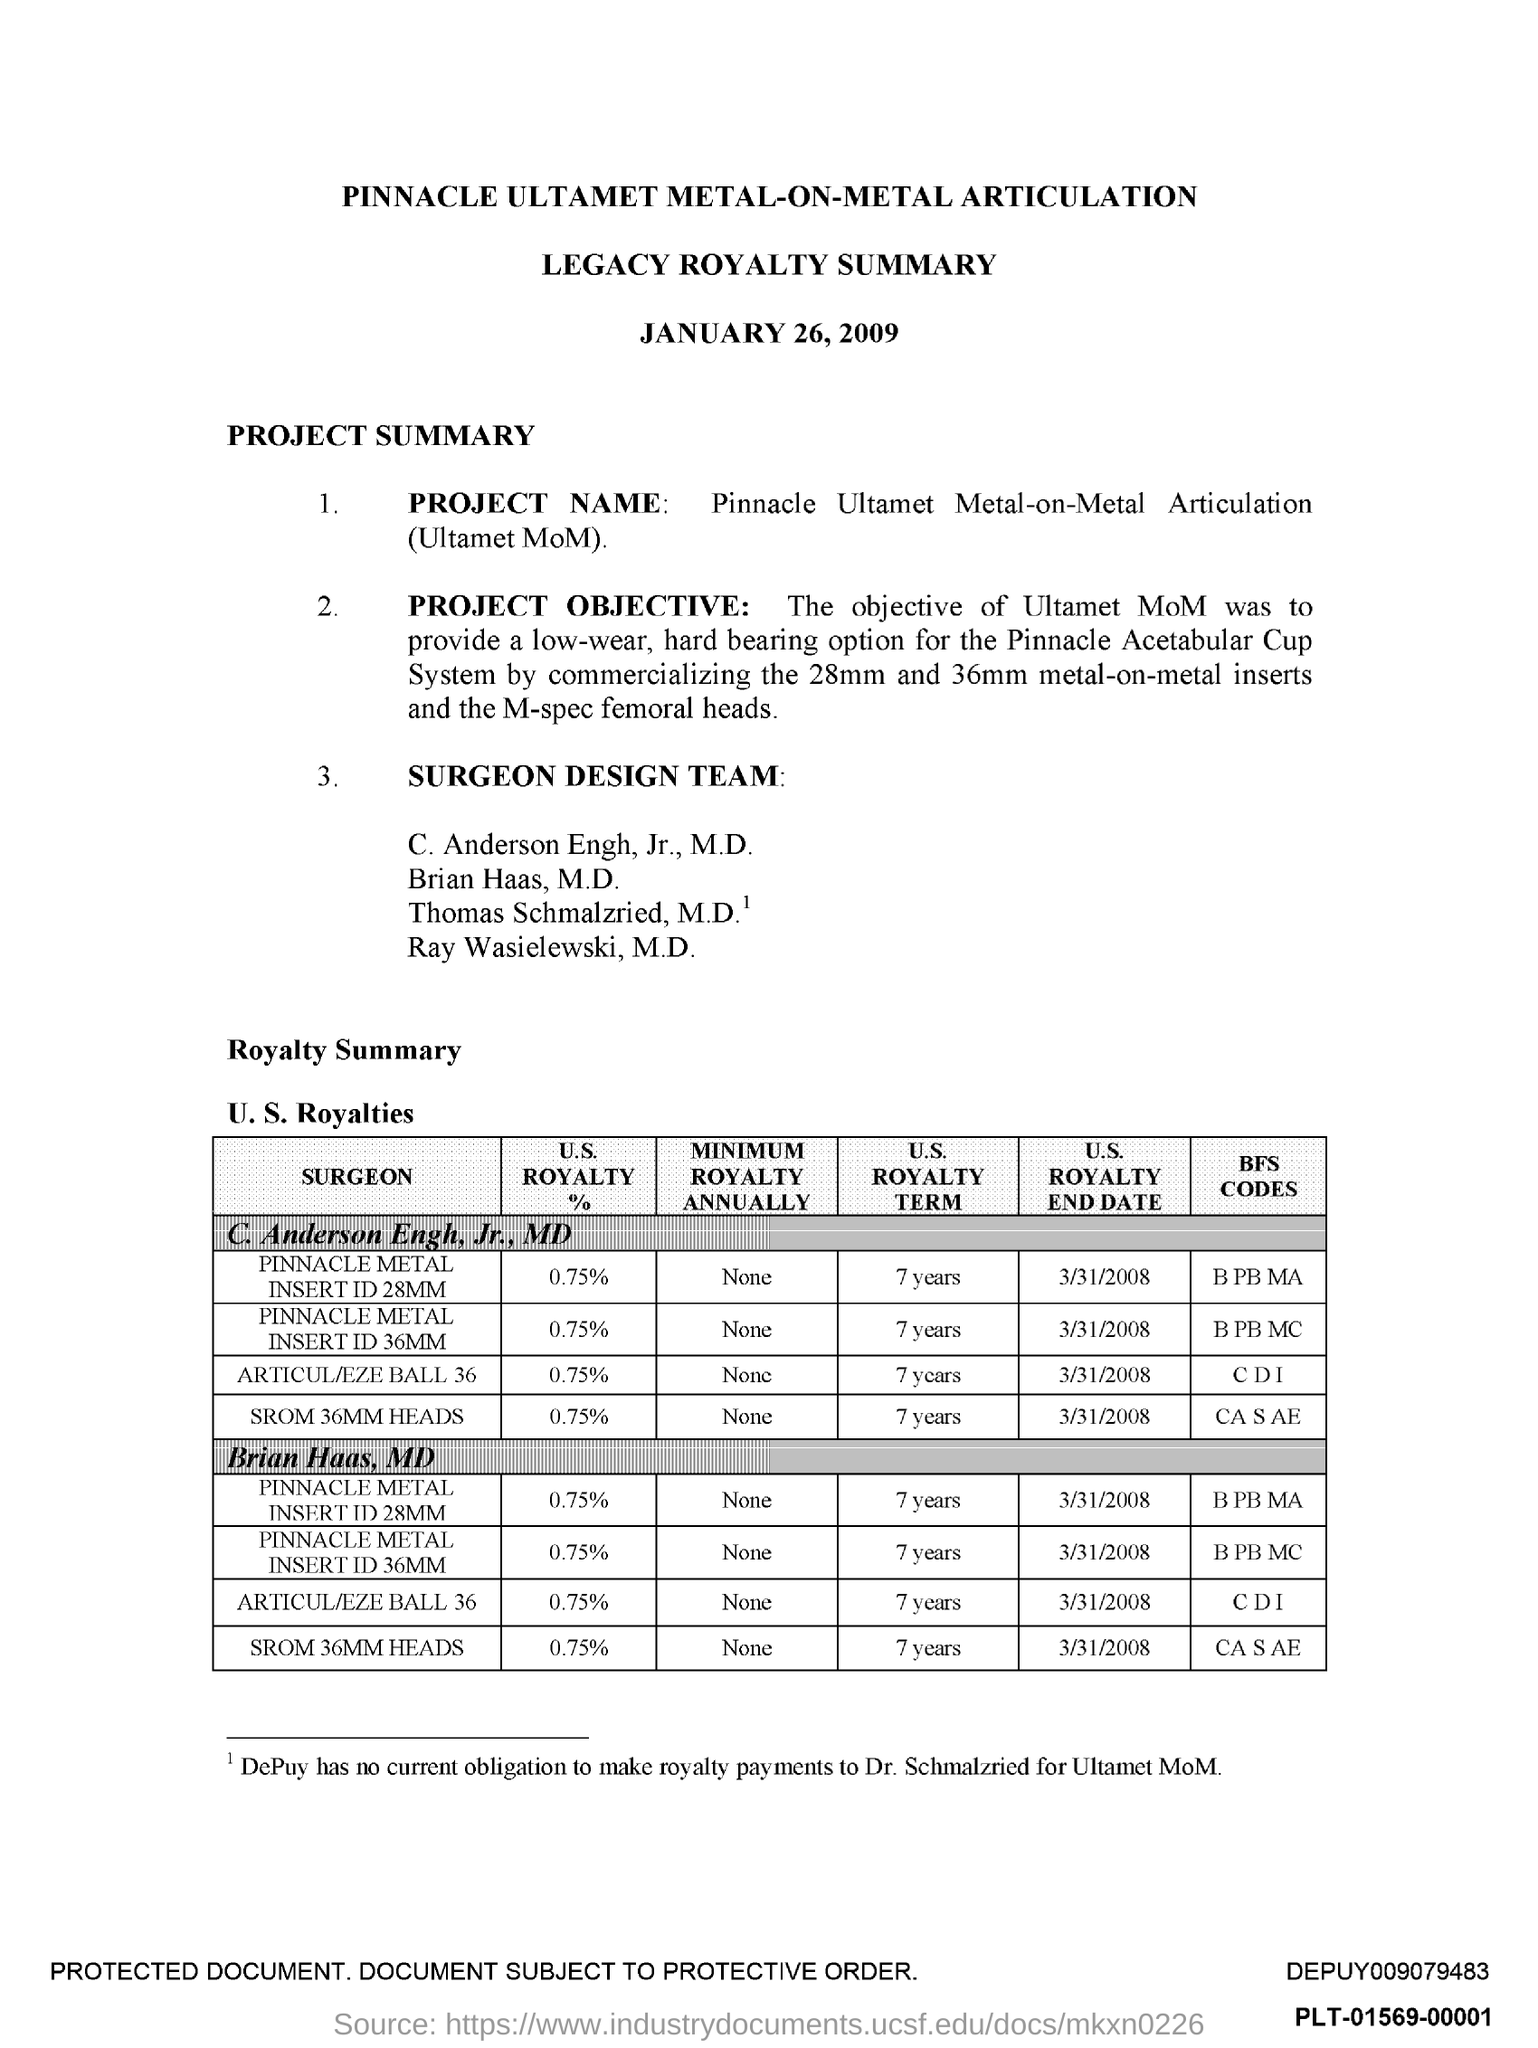Draw attention to some important aspects in this diagram. The title of the document is 'Pinnacle Ultamet Metal-On-Metal Articulation.' The document contains a second title, which is "Legacy Royalty Summary. 